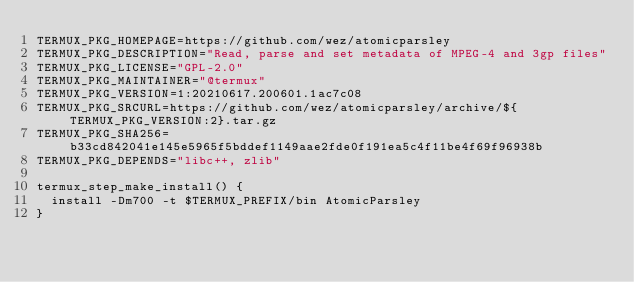Convert code to text. <code><loc_0><loc_0><loc_500><loc_500><_Bash_>TERMUX_PKG_HOMEPAGE=https://github.com/wez/atomicparsley
TERMUX_PKG_DESCRIPTION="Read, parse and set metadata of MPEG-4 and 3gp files"
TERMUX_PKG_LICENSE="GPL-2.0"
TERMUX_PKG_MAINTAINER="@termux"
TERMUX_PKG_VERSION=1:20210617.200601.1ac7c08
TERMUX_PKG_SRCURL=https://github.com/wez/atomicparsley/archive/${TERMUX_PKG_VERSION:2}.tar.gz
TERMUX_PKG_SHA256=b33cd842041e145e5965f5bddef1149aae2fde0f191ea5c4f11be4f69f96938b
TERMUX_PKG_DEPENDS="libc++, zlib"

termux_step_make_install() {
	install -Dm700 -t $TERMUX_PREFIX/bin AtomicParsley
}
</code> 